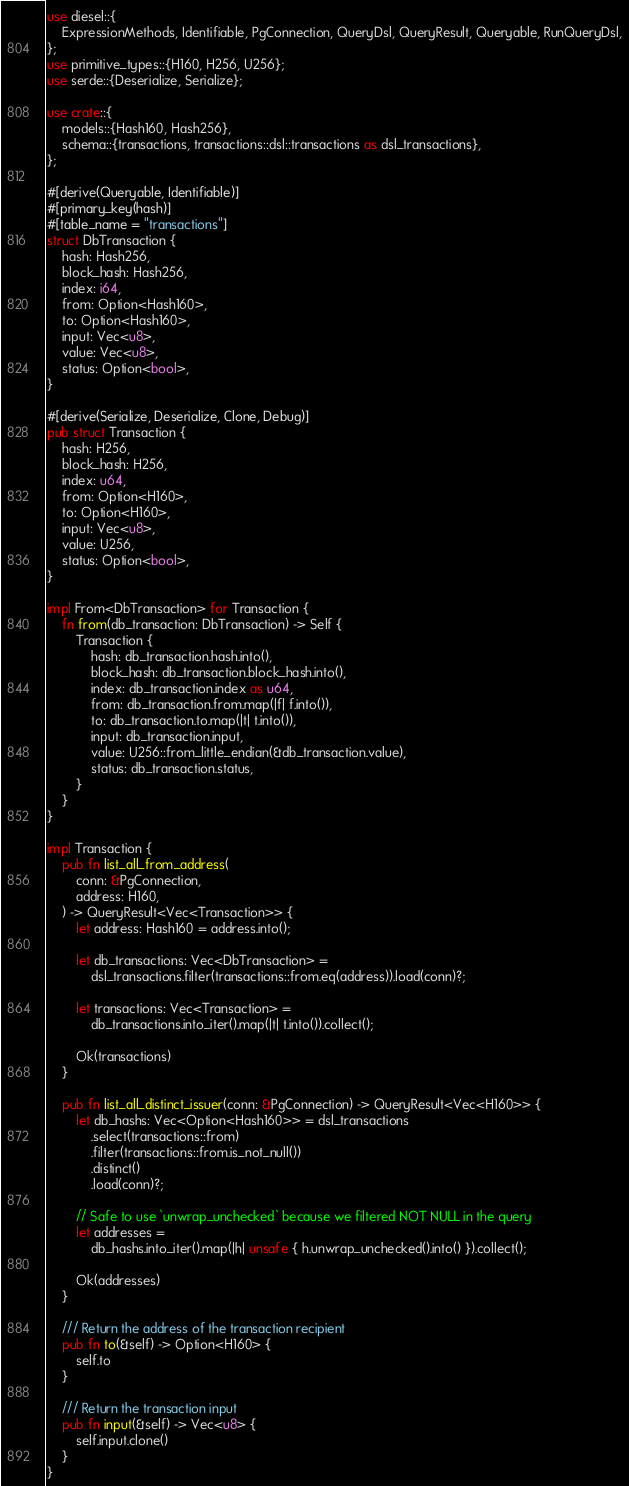<code> <loc_0><loc_0><loc_500><loc_500><_Rust_>use diesel::{
	ExpressionMethods, Identifiable, PgConnection, QueryDsl, QueryResult, Queryable, RunQueryDsl,
};
use primitive_types::{H160, H256, U256};
use serde::{Deserialize, Serialize};

use crate::{
	models::{Hash160, Hash256},
	schema::{transactions, transactions::dsl::transactions as dsl_transactions},
};

#[derive(Queryable, Identifiable)]
#[primary_key(hash)]
#[table_name = "transactions"]
struct DbTransaction {
	hash: Hash256,
	block_hash: Hash256,
	index: i64,
	from: Option<Hash160>,
	to: Option<Hash160>,
	input: Vec<u8>,
	value: Vec<u8>,
	status: Option<bool>,
}

#[derive(Serialize, Deserialize, Clone, Debug)]
pub struct Transaction {
	hash: H256,
	block_hash: H256,
	index: u64,
	from: Option<H160>,
	to: Option<H160>,
	input: Vec<u8>,
	value: U256,
	status: Option<bool>,
}

impl From<DbTransaction> for Transaction {
	fn from(db_transaction: DbTransaction) -> Self {
		Transaction {
			hash: db_transaction.hash.into(),
			block_hash: db_transaction.block_hash.into(),
			index: db_transaction.index as u64,
			from: db_transaction.from.map(|f| f.into()),
			to: db_transaction.to.map(|t| t.into()),
			input: db_transaction.input,
			value: U256::from_little_endian(&db_transaction.value),
			status: db_transaction.status,
		}
	}
}

impl Transaction {
	pub fn list_all_from_address(
		conn: &PgConnection,
		address: H160,
	) -> QueryResult<Vec<Transaction>> {
		let address: Hash160 = address.into();

		let db_transactions: Vec<DbTransaction> =
			dsl_transactions.filter(transactions::from.eq(address)).load(conn)?;

		let transactions: Vec<Transaction> =
			db_transactions.into_iter().map(|t| t.into()).collect();

		Ok(transactions)
	}

	pub fn list_all_distinct_issuer(conn: &PgConnection) -> QueryResult<Vec<H160>> {
		let db_hashs: Vec<Option<Hash160>> = dsl_transactions
			.select(transactions::from)
			.filter(transactions::from.is_not_null())
			.distinct()
			.load(conn)?;

		// Safe to use `unwrap_unchecked` because we filtered NOT NULL in the query
		let addresses =
			db_hashs.into_iter().map(|h| unsafe { h.unwrap_unchecked().into() }).collect();

		Ok(addresses)
	}

	/// Return the address of the transaction recipient
	pub fn to(&self) -> Option<H160> {
		self.to
	}

	/// Return the transaction input
	pub fn input(&self) -> Vec<u8> {
		self.input.clone()
	}
}
</code> 